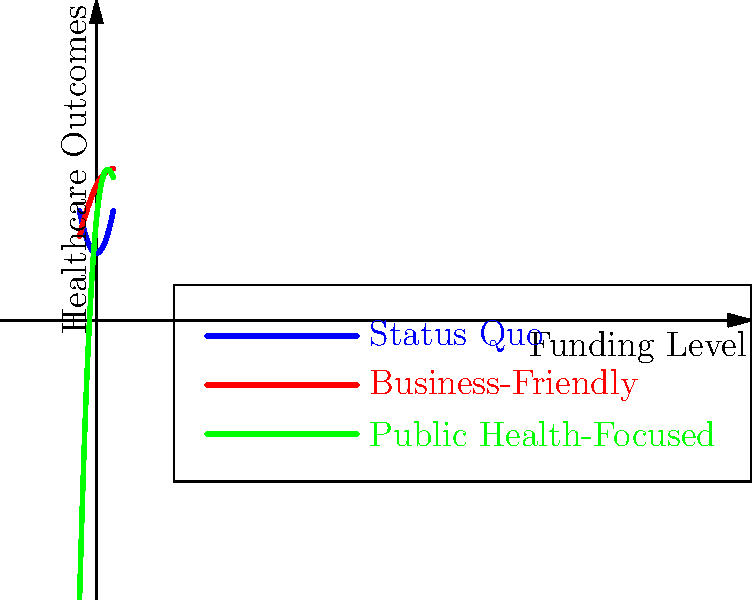The graph shows healthcare outcomes as a function of funding levels under three different policy scenarios. Which policy scenario shows the highest rate of improvement in healthcare outcomes as funding increases from low to moderate levels, and what does this imply about the effectiveness of increased funding in this range? To answer this question, we need to analyze the slopes of the three curves, particularly in the range from low to moderate funding levels (roughly the left half of the graph).

1. Status Quo (Blue curve): This is a simple parabola opening upward. Its slope increases gradually as funding increases.

2. Business-Friendly (Red curve): This is an inverted parabola. Its slope is positive but decreasing as funding increases.

3. Public Health-Focused (Green curve): This is a cubic function. Its slope increases rapidly in the low to moderate funding range.

Comparing these:

- The Status Quo curve shows steady but slow improvement.
- The Business-Friendly curve shows good initial improvement but quickly plateaus.
- The Public Health-Focused curve shows the steepest increase in the low to moderate funding range.

The Public Health-Focused policy shows the highest rate of improvement (steepest slope) in the low to moderate funding range.

This implies that under a Public Health-Focused policy, increased funding in the low to moderate range is highly effective at improving healthcare outcomes. It suggests that targeted public health initiatives may be particularly impactful when resources are limited.
Answer: Public Health-Focused; most effective use of increased funding in low-to-moderate range. 